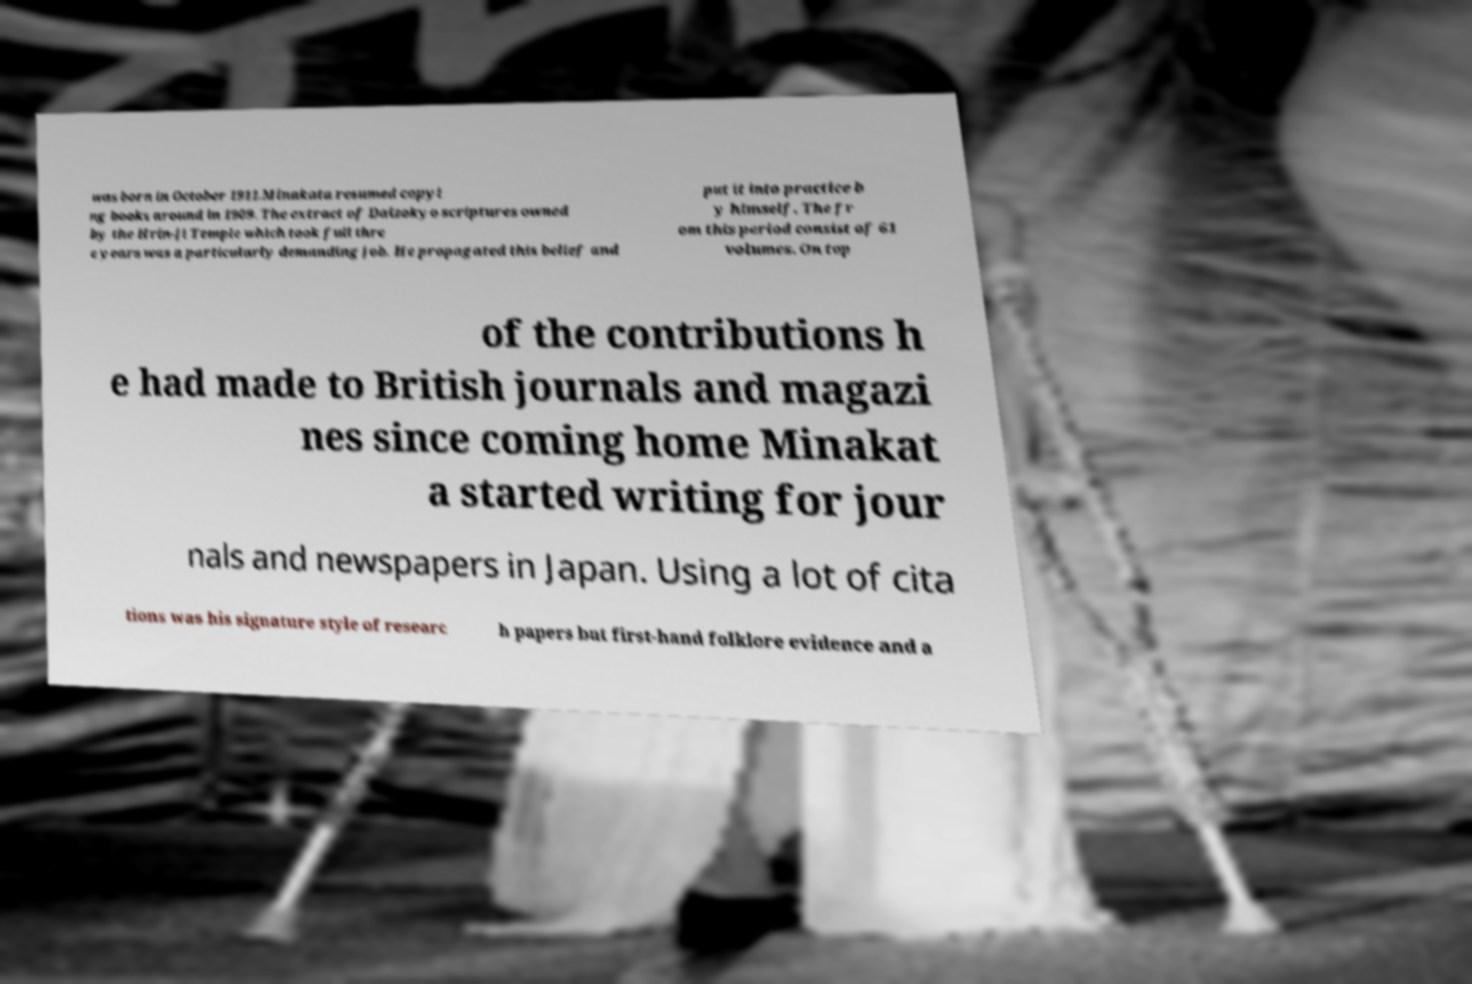I need the written content from this picture converted into text. Can you do that? was born in October 1911.Minakata resumed copyi ng books around in 1909. The extract of Daizokyo scriptures owned by the Hrin-ji Temple which took full thre e years was a particularly demanding job. He propagated this belief and put it into practice b y himself. The fr om this period consist of 61 volumes. On top of the contributions h e had made to British journals and magazi nes since coming home Minakat a started writing for jour nals and newspapers in Japan. Using a lot of cita tions was his signature style of researc h papers but first-hand folklore evidence and a 